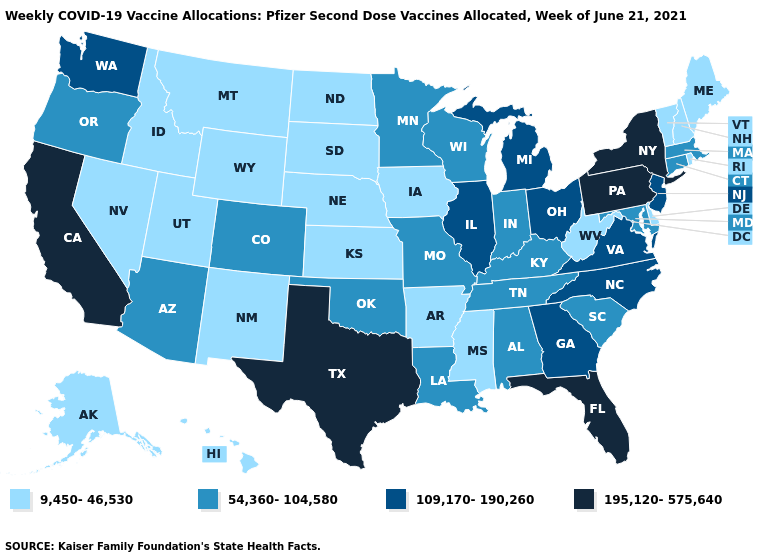What is the lowest value in states that border Maine?
Be succinct. 9,450-46,530. Name the states that have a value in the range 195,120-575,640?
Give a very brief answer. California, Florida, New York, Pennsylvania, Texas. What is the value of Nebraska?
Quick response, please. 9,450-46,530. Does California have the highest value in the West?
Be succinct. Yes. Name the states that have a value in the range 109,170-190,260?
Answer briefly. Georgia, Illinois, Michigan, New Jersey, North Carolina, Ohio, Virginia, Washington. Does Indiana have the lowest value in the MidWest?
Short answer required. No. What is the value of Wyoming?
Give a very brief answer. 9,450-46,530. Does the first symbol in the legend represent the smallest category?
Write a very short answer. Yes. How many symbols are there in the legend?
Be succinct. 4. Name the states that have a value in the range 9,450-46,530?
Give a very brief answer. Alaska, Arkansas, Delaware, Hawaii, Idaho, Iowa, Kansas, Maine, Mississippi, Montana, Nebraska, Nevada, New Hampshire, New Mexico, North Dakota, Rhode Island, South Dakota, Utah, Vermont, West Virginia, Wyoming. What is the value of Rhode Island?
Give a very brief answer. 9,450-46,530. Name the states that have a value in the range 195,120-575,640?
Be succinct. California, Florida, New York, Pennsylvania, Texas. Among the states that border New Hampshire , does Maine have the highest value?
Concise answer only. No. Among the states that border Minnesota , does Wisconsin have the highest value?
Write a very short answer. Yes. Among the states that border Arkansas , which have the highest value?
Write a very short answer. Texas. 